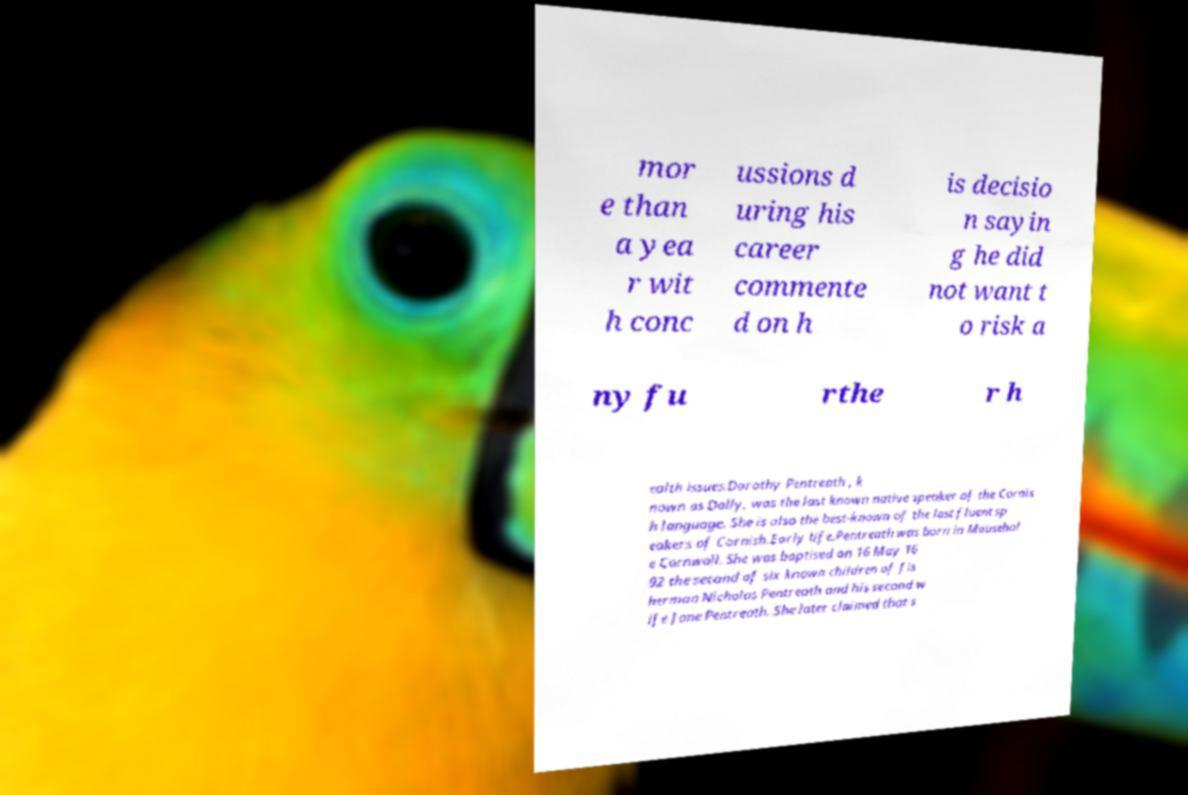For documentation purposes, I need the text within this image transcribed. Could you provide that? mor e than a yea r wit h conc ussions d uring his career commente d on h is decisio n sayin g he did not want t o risk a ny fu rthe r h ealth issues.Dorothy Pentreath , k nown as Dolly, was the last known native speaker of the Cornis h language. She is also the best-known of the last fluent sp eakers of Cornish.Early life.Pentreath was born in Mousehol e Cornwall. She was baptised on 16 May 16 92 the second of six known children of fis herman Nicholas Pentreath and his second w ife Jone Pentreath. She later claimed that s 